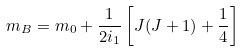<formula> <loc_0><loc_0><loc_500><loc_500>m _ { B } = m _ { 0 } + \frac { 1 } { 2 i _ { 1 } } \left [ J ( J + 1 ) + \frac { 1 } { 4 } \right ]</formula> 